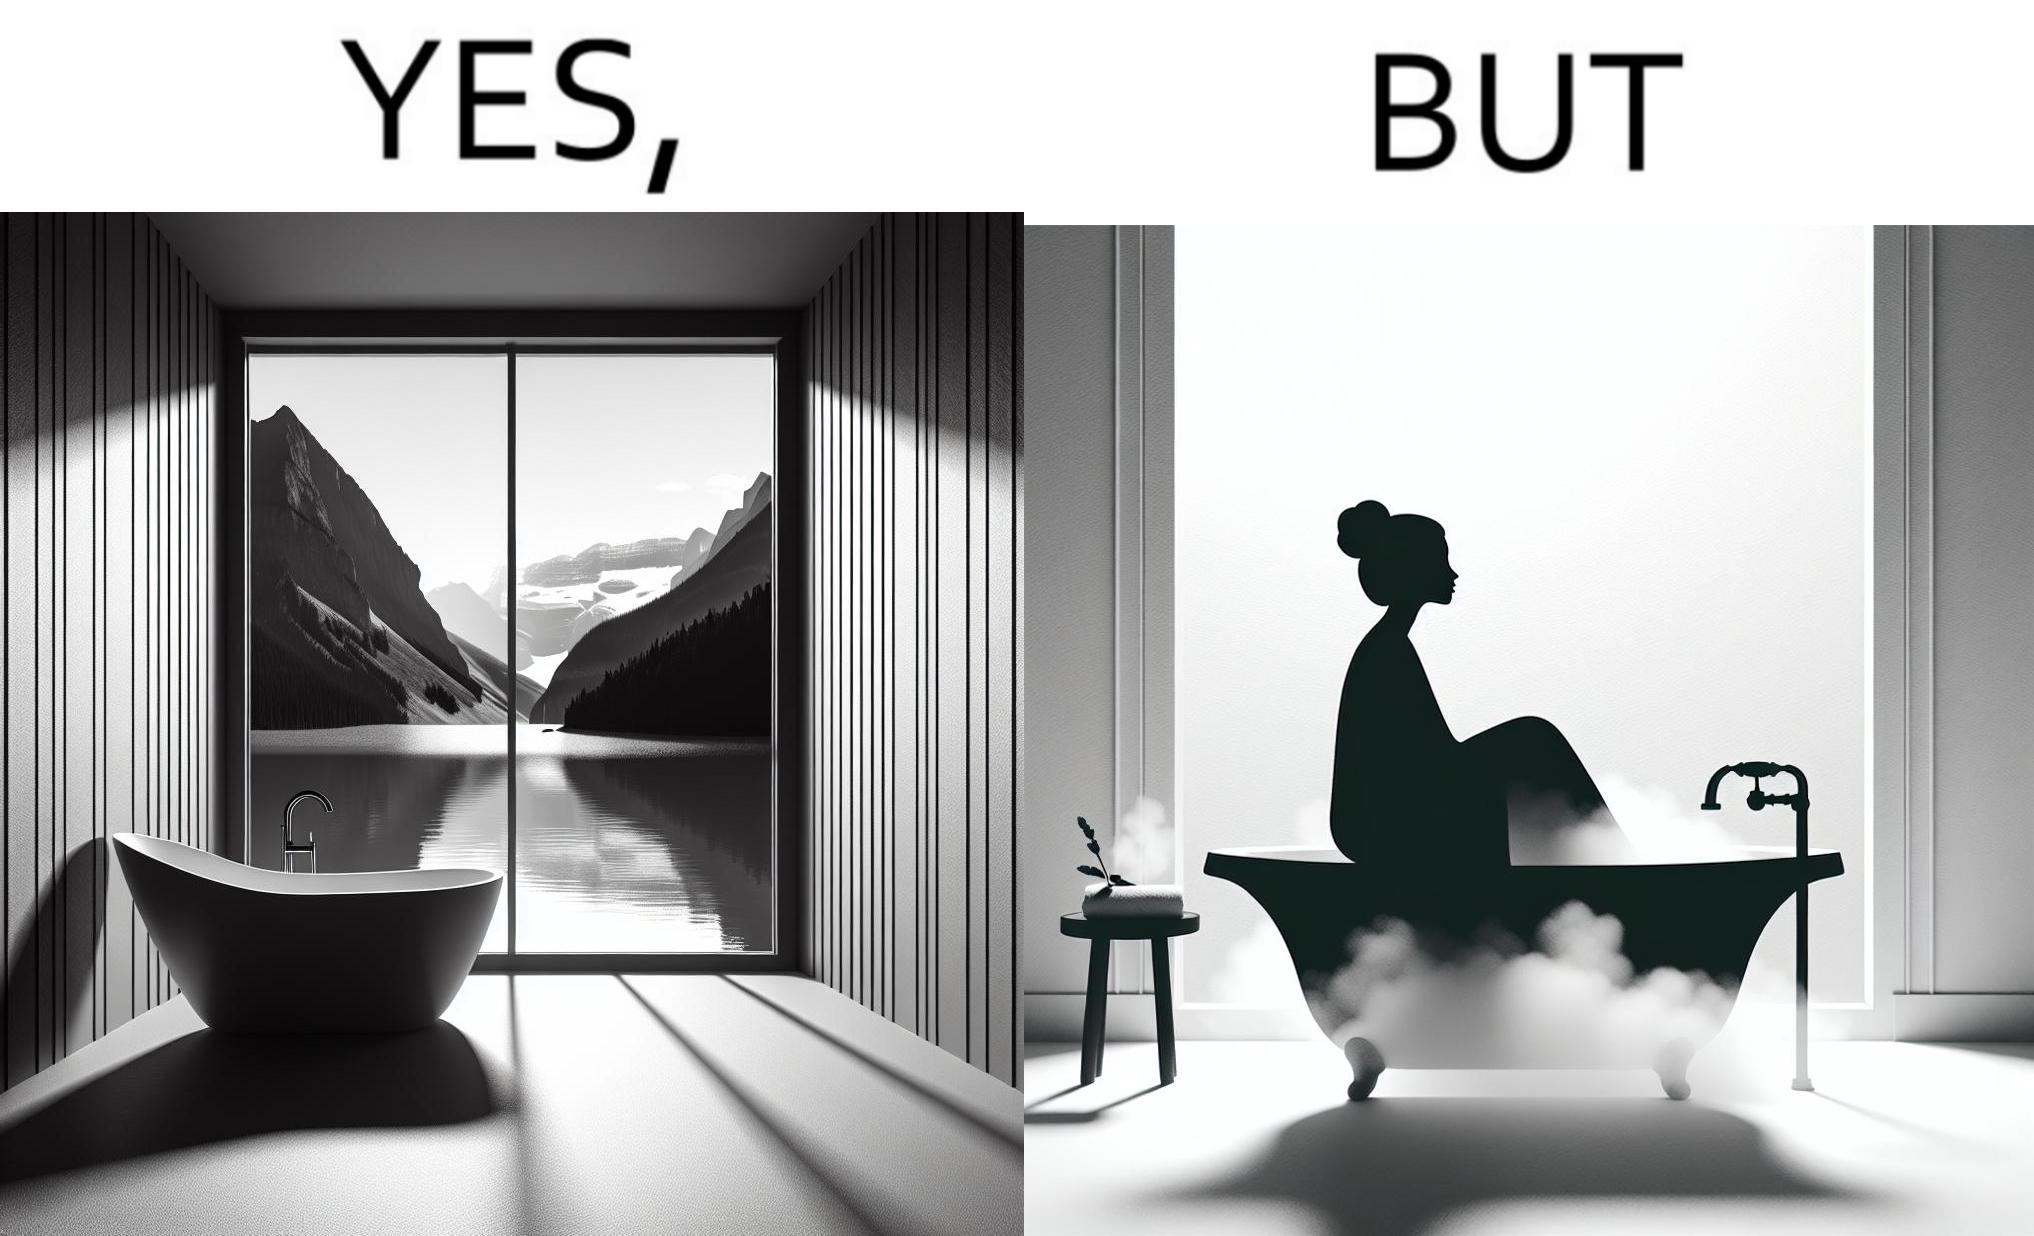Describe what you see in the left and right parts of this image. In the left part of the image: a bathtub by the side of a window which has a very scenic view of lake and mountains. In the right part of the image: a woman bathing in a bathtub, while the window glasses are foggy from the steam of the hot water. 